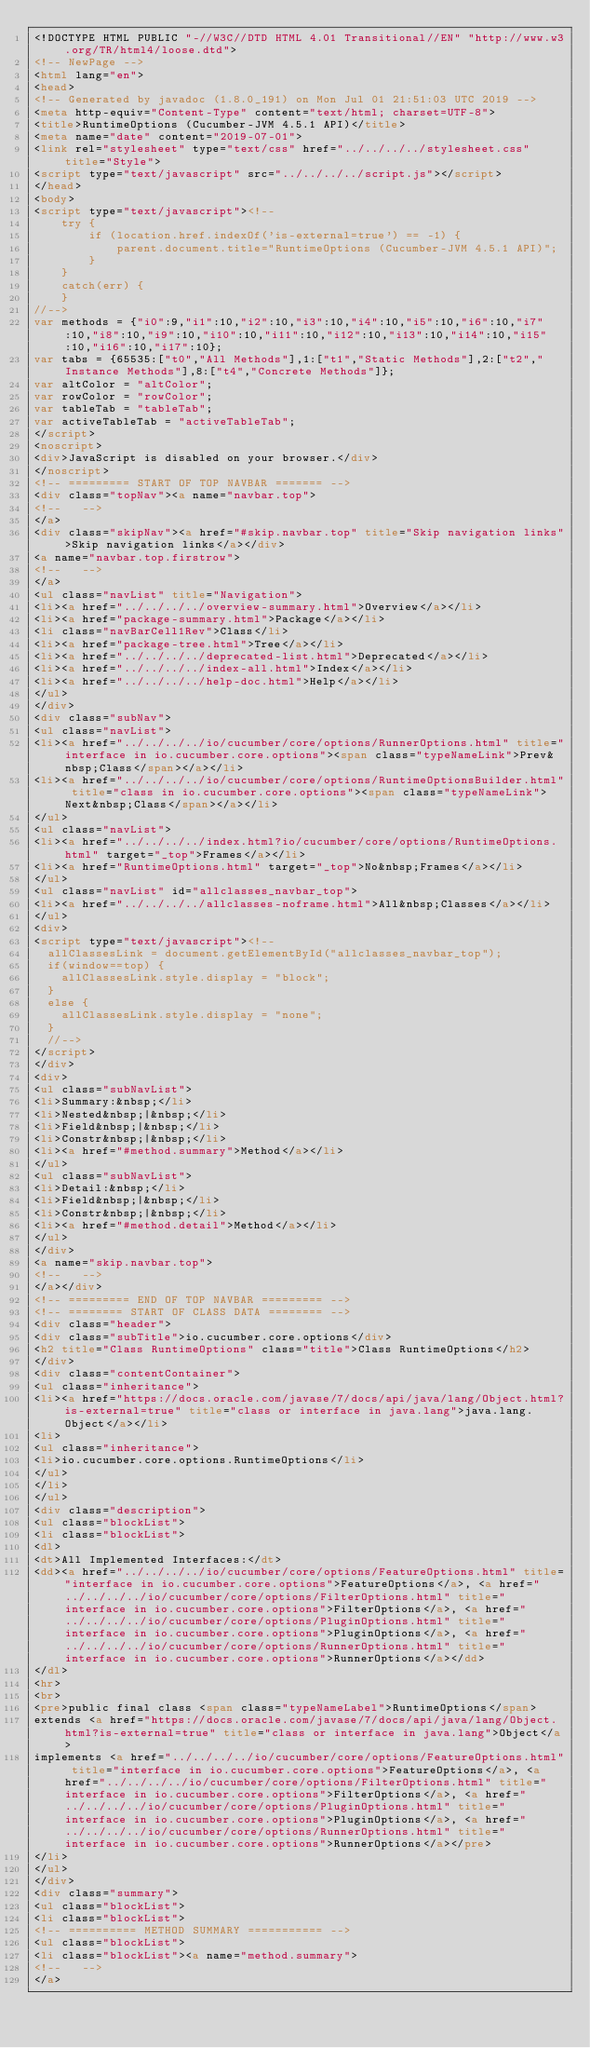Convert code to text. <code><loc_0><loc_0><loc_500><loc_500><_HTML_><!DOCTYPE HTML PUBLIC "-//W3C//DTD HTML 4.01 Transitional//EN" "http://www.w3.org/TR/html4/loose.dtd">
<!-- NewPage -->
<html lang="en">
<head>
<!-- Generated by javadoc (1.8.0_191) on Mon Jul 01 21:51:03 UTC 2019 -->
<meta http-equiv="Content-Type" content="text/html; charset=UTF-8">
<title>RuntimeOptions (Cucumber-JVM 4.5.1 API)</title>
<meta name="date" content="2019-07-01">
<link rel="stylesheet" type="text/css" href="../../../../stylesheet.css" title="Style">
<script type="text/javascript" src="../../../../script.js"></script>
</head>
<body>
<script type="text/javascript"><!--
    try {
        if (location.href.indexOf('is-external=true') == -1) {
            parent.document.title="RuntimeOptions (Cucumber-JVM 4.5.1 API)";
        }
    }
    catch(err) {
    }
//-->
var methods = {"i0":9,"i1":10,"i2":10,"i3":10,"i4":10,"i5":10,"i6":10,"i7":10,"i8":10,"i9":10,"i10":10,"i11":10,"i12":10,"i13":10,"i14":10,"i15":10,"i16":10,"i17":10};
var tabs = {65535:["t0","All Methods"],1:["t1","Static Methods"],2:["t2","Instance Methods"],8:["t4","Concrete Methods"]};
var altColor = "altColor";
var rowColor = "rowColor";
var tableTab = "tableTab";
var activeTableTab = "activeTableTab";
</script>
<noscript>
<div>JavaScript is disabled on your browser.</div>
</noscript>
<!-- ========= START OF TOP NAVBAR ======= -->
<div class="topNav"><a name="navbar.top">
<!--   -->
</a>
<div class="skipNav"><a href="#skip.navbar.top" title="Skip navigation links">Skip navigation links</a></div>
<a name="navbar.top.firstrow">
<!--   -->
</a>
<ul class="navList" title="Navigation">
<li><a href="../../../../overview-summary.html">Overview</a></li>
<li><a href="package-summary.html">Package</a></li>
<li class="navBarCell1Rev">Class</li>
<li><a href="package-tree.html">Tree</a></li>
<li><a href="../../../../deprecated-list.html">Deprecated</a></li>
<li><a href="../../../../index-all.html">Index</a></li>
<li><a href="../../../../help-doc.html">Help</a></li>
</ul>
</div>
<div class="subNav">
<ul class="navList">
<li><a href="../../../../io/cucumber/core/options/RunnerOptions.html" title="interface in io.cucumber.core.options"><span class="typeNameLink">Prev&nbsp;Class</span></a></li>
<li><a href="../../../../io/cucumber/core/options/RuntimeOptionsBuilder.html" title="class in io.cucumber.core.options"><span class="typeNameLink">Next&nbsp;Class</span></a></li>
</ul>
<ul class="navList">
<li><a href="../../../../index.html?io/cucumber/core/options/RuntimeOptions.html" target="_top">Frames</a></li>
<li><a href="RuntimeOptions.html" target="_top">No&nbsp;Frames</a></li>
</ul>
<ul class="navList" id="allclasses_navbar_top">
<li><a href="../../../../allclasses-noframe.html">All&nbsp;Classes</a></li>
</ul>
<div>
<script type="text/javascript"><!--
  allClassesLink = document.getElementById("allclasses_navbar_top");
  if(window==top) {
    allClassesLink.style.display = "block";
  }
  else {
    allClassesLink.style.display = "none";
  }
  //-->
</script>
</div>
<div>
<ul class="subNavList">
<li>Summary:&nbsp;</li>
<li>Nested&nbsp;|&nbsp;</li>
<li>Field&nbsp;|&nbsp;</li>
<li>Constr&nbsp;|&nbsp;</li>
<li><a href="#method.summary">Method</a></li>
</ul>
<ul class="subNavList">
<li>Detail:&nbsp;</li>
<li>Field&nbsp;|&nbsp;</li>
<li>Constr&nbsp;|&nbsp;</li>
<li><a href="#method.detail">Method</a></li>
</ul>
</div>
<a name="skip.navbar.top">
<!--   -->
</a></div>
<!-- ========= END OF TOP NAVBAR ========= -->
<!-- ======== START OF CLASS DATA ======== -->
<div class="header">
<div class="subTitle">io.cucumber.core.options</div>
<h2 title="Class RuntimeOptions" class="title">Class RuntimeOptions</h2>
</div>
<div class="contentContainer">
<ul class="inheritance">
<li><a href="https://docs.oracle.com/javase/7/docs/api/java/lang/Object.html?is-external=true" title="class or interface in java.lang">java.lang.Object</a></li>
<li>
<ul class="inheritance">
<li>io.cucumber.core.options.RuntimeOptions</li>
</ul>
</li>
</ul>
<div class="description">
<ul class="blockList">
<li class="blockList">
<dl>
<dt>All Implemented Interfaces:</dt>
<dd><a href="../../../../io/cucumber/core/options/FeatureOptions.html" title="interface in io.cucumber.core.options">FeatureOptions</a>, <a href="../../../../io/cucumber/core/options/FilterOptions.html" title="interface in io.cucumber.core.options">FilterOptions</a>, <a href="../../../../io/cucumber/core/options/PluginOptions.html" title="interface in io.cucumber.core.options">PluginOptions</a>, <a href="../../../../io/cucumber/core/options/RunnerOptions.html" title="interface in io.cucumber.core.options">RunnerOptions</a></dd>
</dl>
<hr>
<br>
<pre>public final class <span class="typeNameLabel">RuntimeOptions</span>
extends <a href="https://docs.oracle.com/javase/7/docs/api/java/lang/Object.html?is-external=true" title="class or interface in java.lang">Object</a>
implements <a href="../../../../io/cucumber/core/options/FeatureOptions.html" title="interface in io.cucumber.core.options">FeatureOptions</a>, <a href="../../../../io/cucumber/core/options/FilterOptions.html" title="interface in io.cucumber.core.options">FilterOptions</a>, <a href="../../../../io/cucumber/core/options/PluginOptions.html" title="interface in io.cucumber.core.options">PluginOptions</a>, <a href="../../../../io/cucumber/core/options/RunnerOptions.html" title="interface in io.cucumber.core.options">RunnerOptions</a></pre>
</li>
</ul>
</div>
<div class="summary">
<ul class="blockList">
<li class="blockList">
<!-- ========== METHOD SUMMARY =========== -->
<ul class="blockList">
<li class="blockList"><a name="method.summary">
<!--   -->
</a></code> 